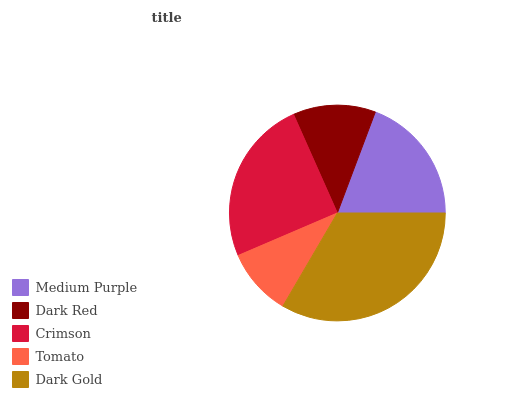Is Tomato the minimum?
Answer yes or no. Yes. Is Dark Gold the maximum?
Answer yes or no. Yes. Is Dark Red the minimum?
Answer yes or no. No. Is Dark Red the maximum?
Answer yes or no. No. Is Medium Purple greater than Dark Red?
Answer yes or no. Yes. Is Dark Red less than Medium Purple?
Answer yes or no. Yes. Is Dark Red greater than Medium Purple?
Answer yes or no. No. Is Medium Purple less than Dark Red?
Answer yes or no. No. Is Medium Purple the high median?
Answer yes or no. Yes. Is Medium Purple the low median?
Answer yes or no. Yes. Is Crimson the high median?
Answer yes or no. No. Is Tomato the low median?
Answer yes or no. No. 